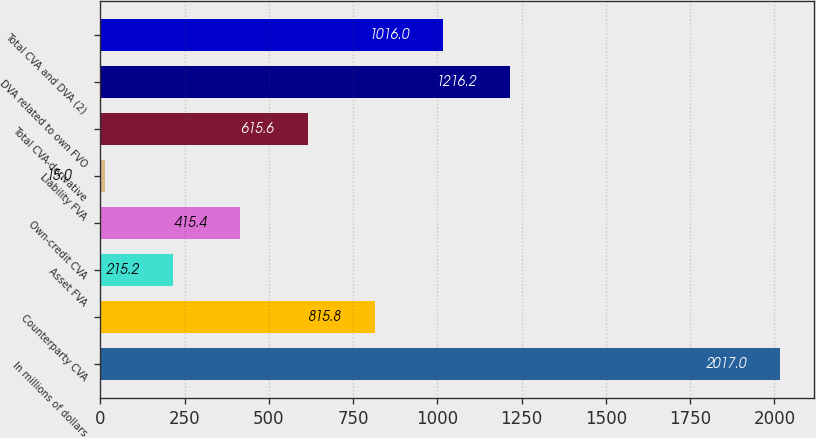<chart> <loc_0><loc_0><loc_500><loc_500><bar_chart><fcel>In millions of dollars<fcel>Counterparty CVA<fcel>Asset FVA<fcel>Own-credit CVA<fcel>Liability FVA<fcel>Total CVA-derivative<fcel>DVA related to own FVO<fcel>Total CVA and DVA (2)<nl><fcel>2017<fcel>815.8<fcel>215.2<fcel>415.4<fcel>15<fcel>615.6<fcel>1216.2<fcel>1016<nl></chart> 